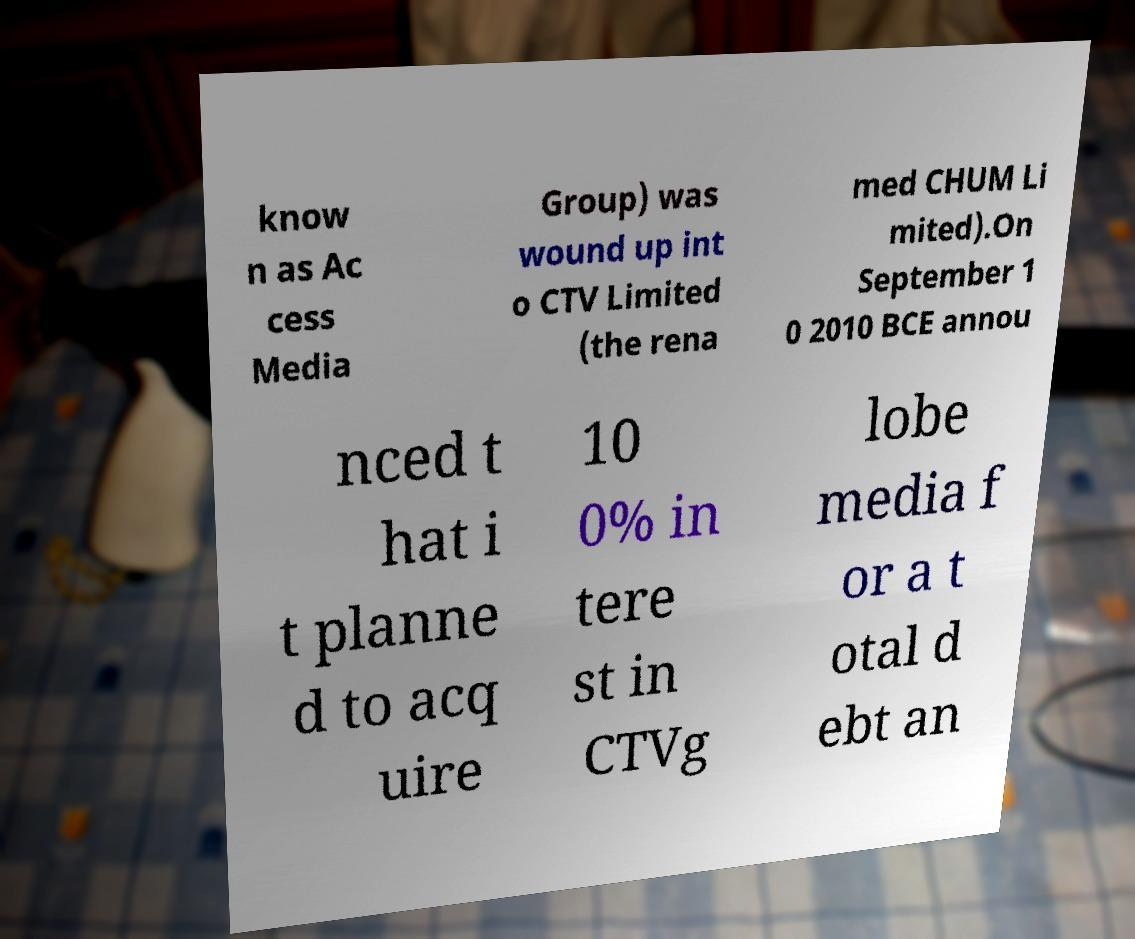Could you extract and type out the text from this image? know n as Ac cess Media Group) was wound up int o CTV Limited (the rena med CHUM Li mited).On September 1 0 2010 BCE annou nced t hat i t planne d to acq uire 10 0% in tere st in CTVg lobe media f or a t otal d ebt an 